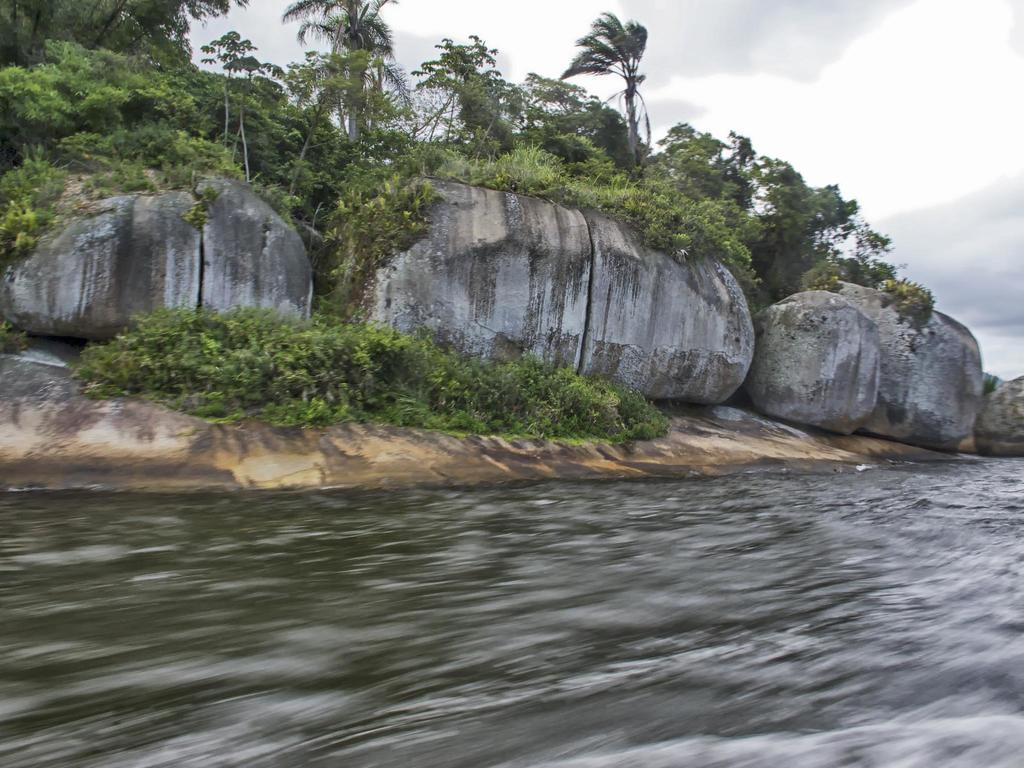In one or two sentences, can you explain what this image depicts? At the bottom of the image there is water. In the background of the image there are rocks, plants, trees. At the top of the image there is sky and clouds. 